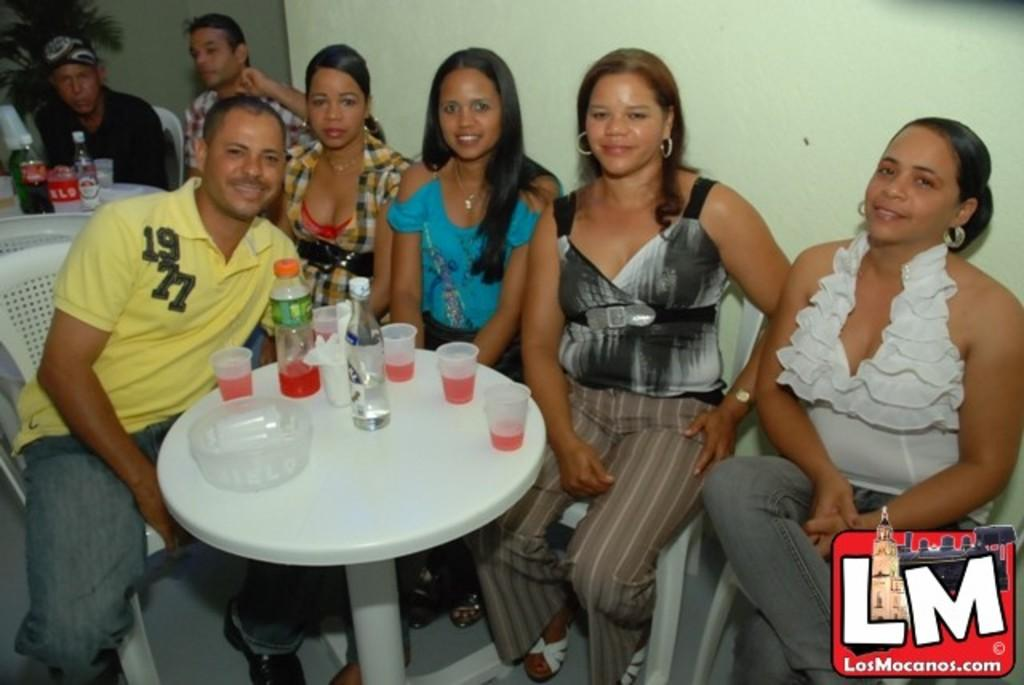How many people are in the image? There is a group of people in the image. What are the people doing in the image? The people are sitting in front of a table. What objects can be seen on the table? There are two bottles and glasses on the table. What is located at the back of the image? There is a plant at the back of the image. What type of desk is visible in the image? There is no desk present in the image. 